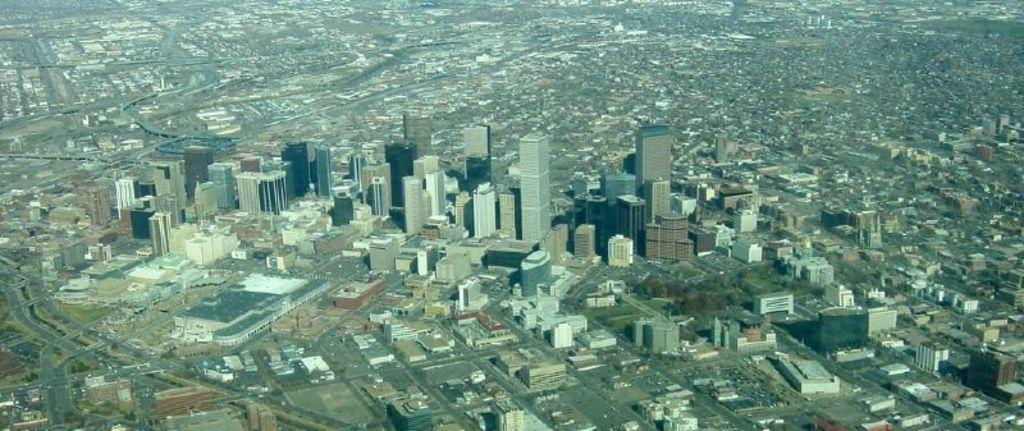Can you describe this image briefly? In this image we can see there are so many buildings and trees. 